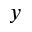<formula> <loc_0><loc_0><loc_500><loc_500>y</formula> 